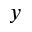<formula> <loc_0><loc_0><loc_500><loc_500>y</formula> 